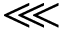<formula> <loc_0><loc_0><loc_500><loc_500>\lll</formula> 